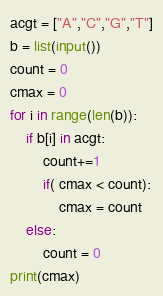Convert code to text. <code><loc_0><loc_0><loc_500><loc_500><_Python_>acgt = ["A","C","G","T"]
b = list(input())
count = 0
cmax = 0
for i in range(len(b)):
    if b[i] in acgt:
        count+=1
        if( cmax < count):
            cmax = count
    else:
        count = 0
print(cmax)</code> 